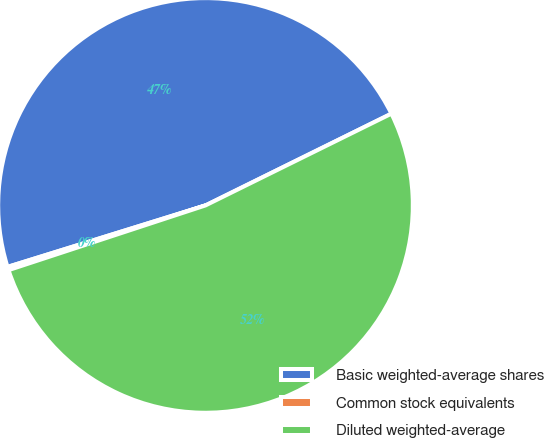Convert chart. <chart><loc_0><loc_0><loc_500><loc_500><pie_chart><fcel>Basic weighted-average shares<fcel>Common stock equivalents<fcel>Diluted weighted-average<nl><fcel>47.49%<fcel>0.26%<fcel>52.24%<nl></chart> 